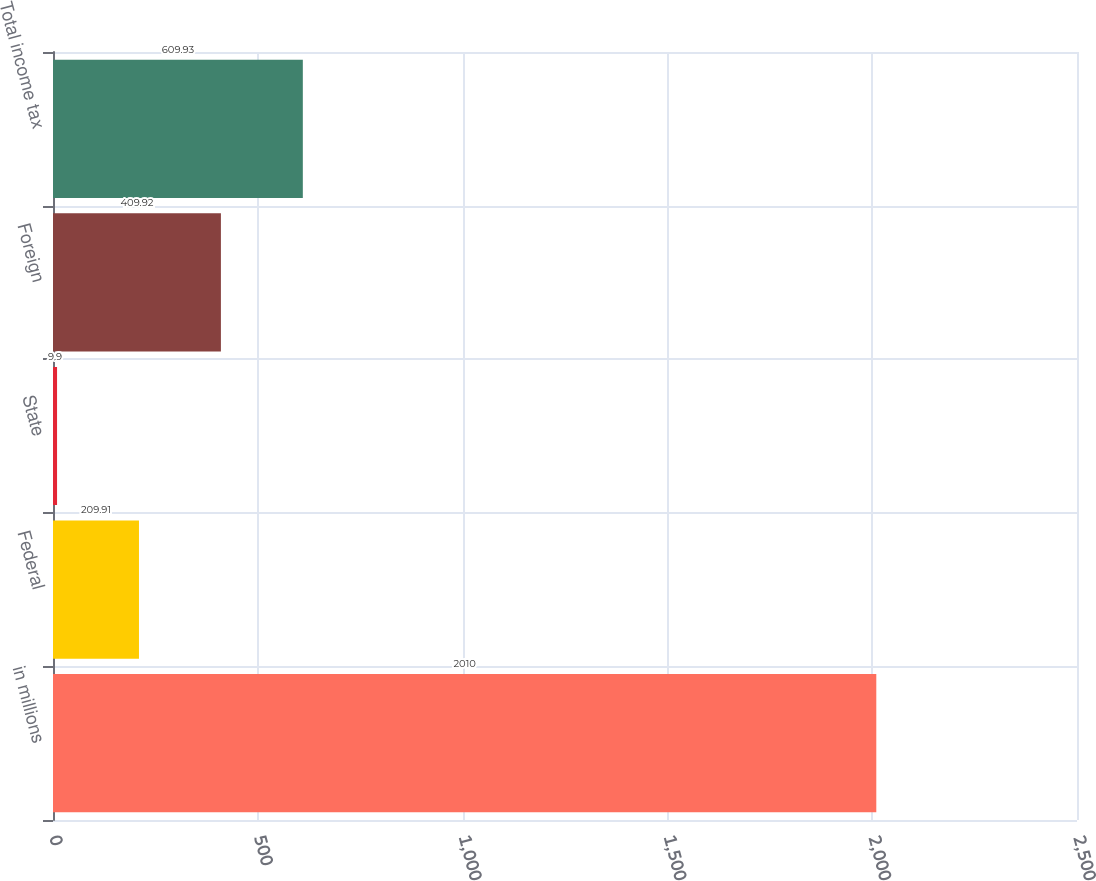Convert chart to OTSL. <chart><loc_0><loc_0><loc_500><loc_500><bar_chart><fcel>in millions<fcel>Federal<fcel>State<fcel>Foreign<fcel>Total income tax<nl><fcel>2010<fcel>209.91<fcel>9.9<fcel>409.92<fcel>609.93<nl></chart> 